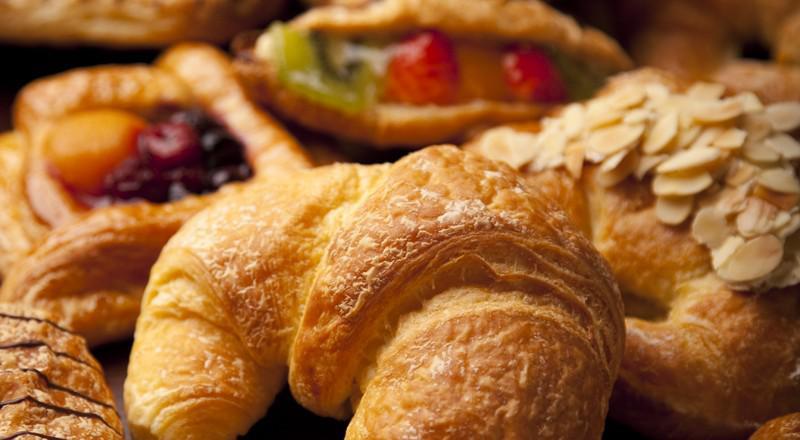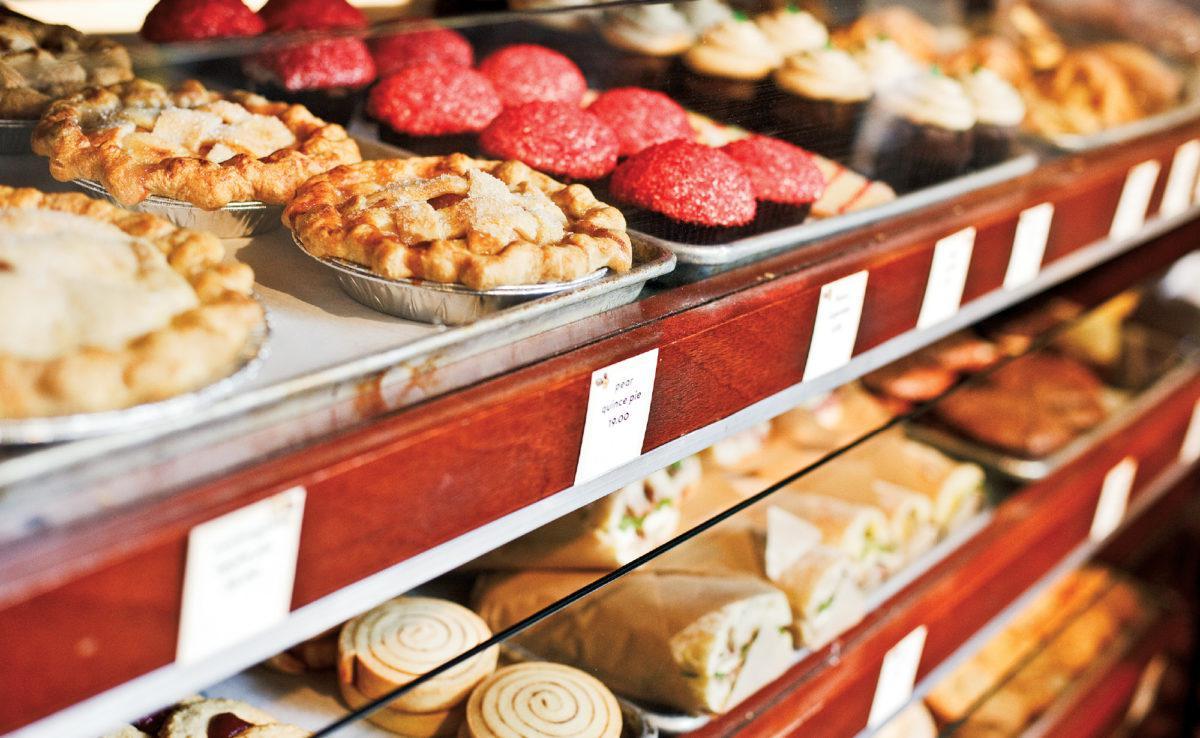The first image is the image on the left, the second image is the image on the right. Assess this claim about the two images: "One image shows individual stands holding cards in front of bakery items laid out on counter.". Correct or not? Answer yes or no. No. The first image is the image on the left, the second image is the image on the right. Assess this claim about the two images: "The pastries in the right image are labeled, and the ones in the left image are not.". Correct or not? Answer yes or no. Yes. 